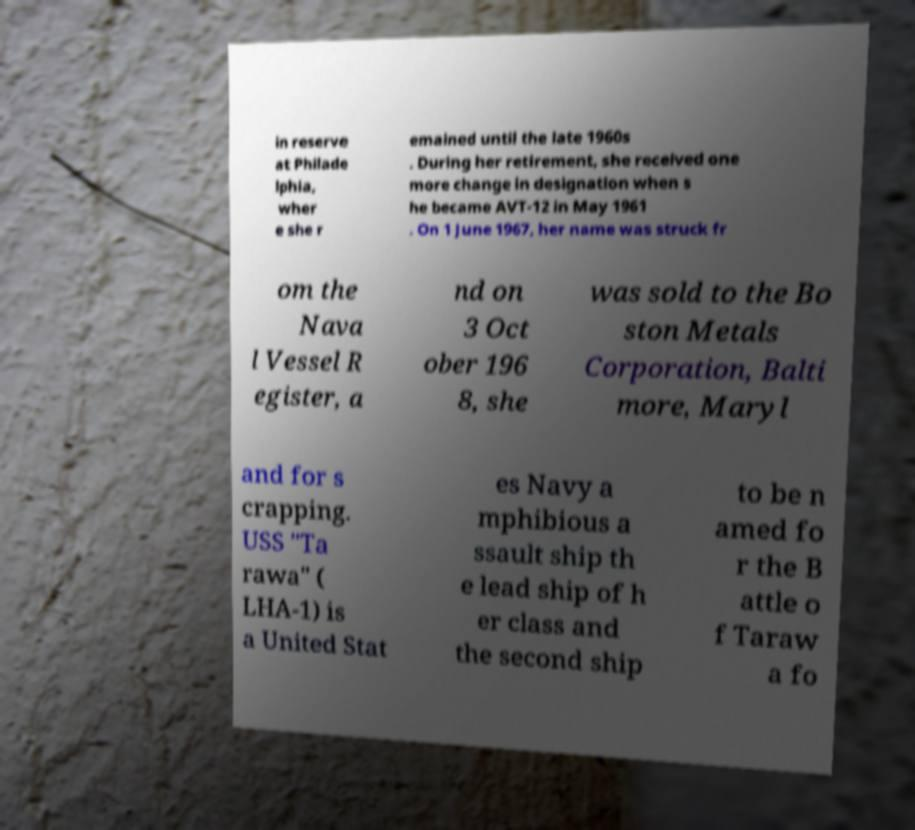For documentation purposes, I need the text within this image transcribed. Could you provide that? in reserve at Philade lphia, wher e she r emained until the late 1960s . During her retirement, she received one more change in designation when s he became AVT-12 in May 1961 . On 1 June 1967, her name was struck fr om the Nava l Vessel R egister, a nd on 3 Oct ober 196 8, she was sold to the Bo ston Metals Corporation, Balti more, Maryl and for s crapping. USS "Ta rawa" ( LHA-1) is a United Stat es Navy a mphibious a ssault ship th e lead ship of h er class and the second ship to be n amed fo r the B attle o f Taraw a fo 